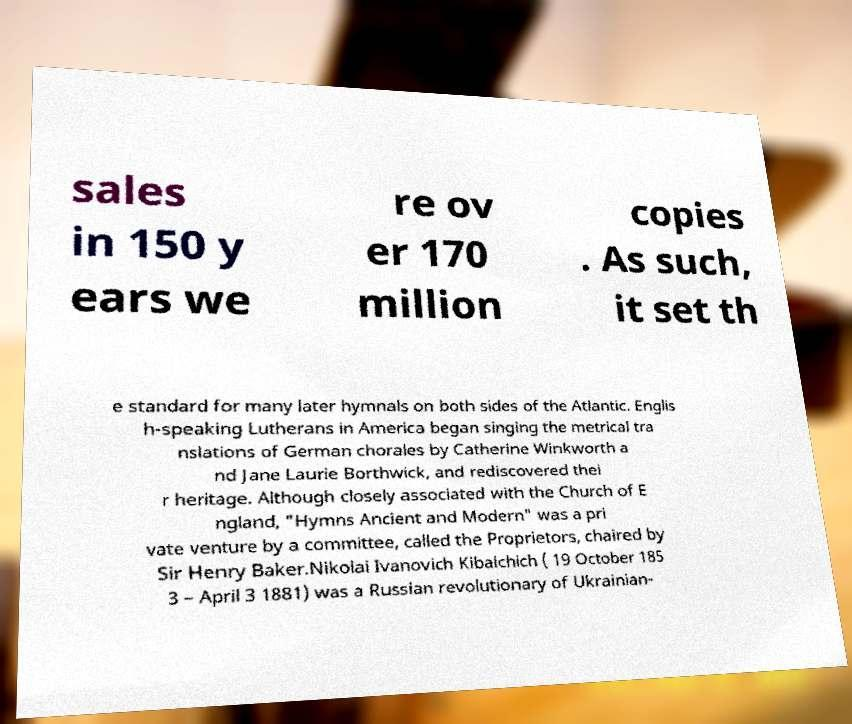Can you accurately transcribe the text from the provided image for me? sales in 150 y ears we re ov er 170 million copies . As such, it set th e standard for many later hymnals on both sides of the Atlantic. Englis h-speaking Lutherans in America began singing the metrical tra nslations of German chorales by Catherine Winkworth a nd Jane Laurie Borthwick, and rediscovered thei r heritage. Although closely associated with the Church of E ngland, "Hymns Ancient and Modern" was a pri vate venture by a committee, called the Proprietors, chaired by Sir Henry Baker.Nikolai Ivanovich Kibalchich ( 19 October 185 3 – April 3 1881) was a Russian revolutionary of Ukrainian- 